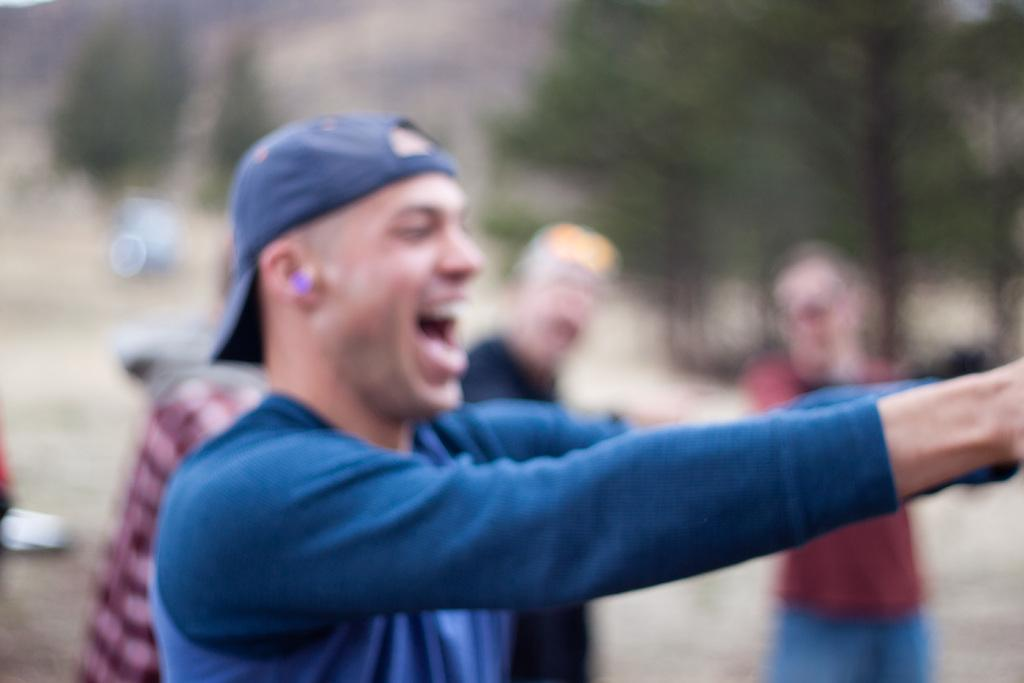What is the person in the image wearing? The person is wearing a blue dress and a cap. How many people are visible in the image? There is one person standing in the image, and three persons standing in the background. What can be seen in the background of the image? There are trees visible in the background of the image, and the background is blurred. What type of stamp is the person holding in the image? There is no stamp present in the image; the person is wearing a cap and standing in front of trees. 